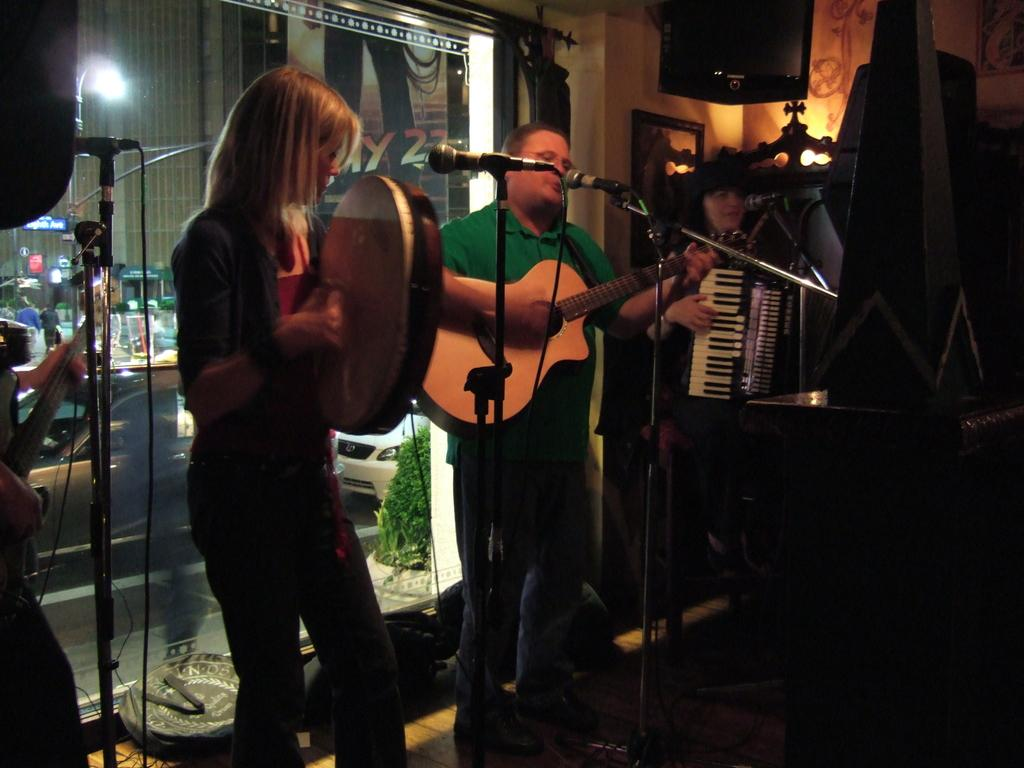Who are the people in the image? There is a man and a woman in the image. What are the man and woman doing in the image? The man and woman are playing guitars. What other musical instrument can be seen in the image? There is a sousaphone in the image. What might be used for amplifying their voices or instruments in the image? There is a microphone in the image. How many clocks are visible on the wall in the image? There are no clocks visible on the wall in the image. Is there a stream running through the background of the image? There is no stream present in the image. 